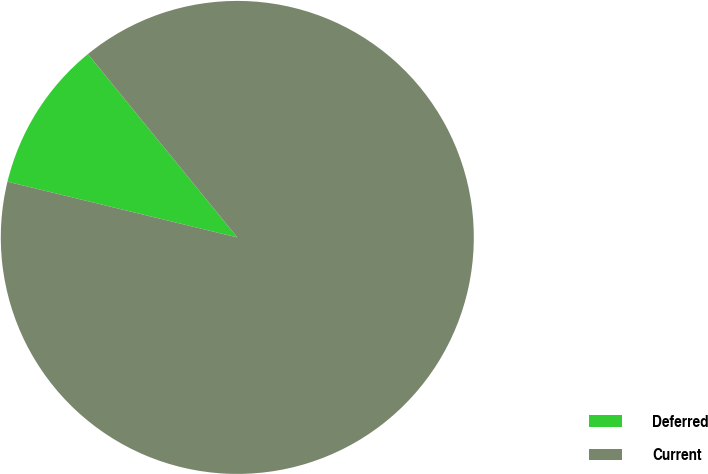Convert chart. <chart><loc_0><loc_0><loc_500><loc_500><pie_chart><fcel>Deferred<fcel>Current<nl><fcel>10.33%<fcel>89.67%<nl></chart> 